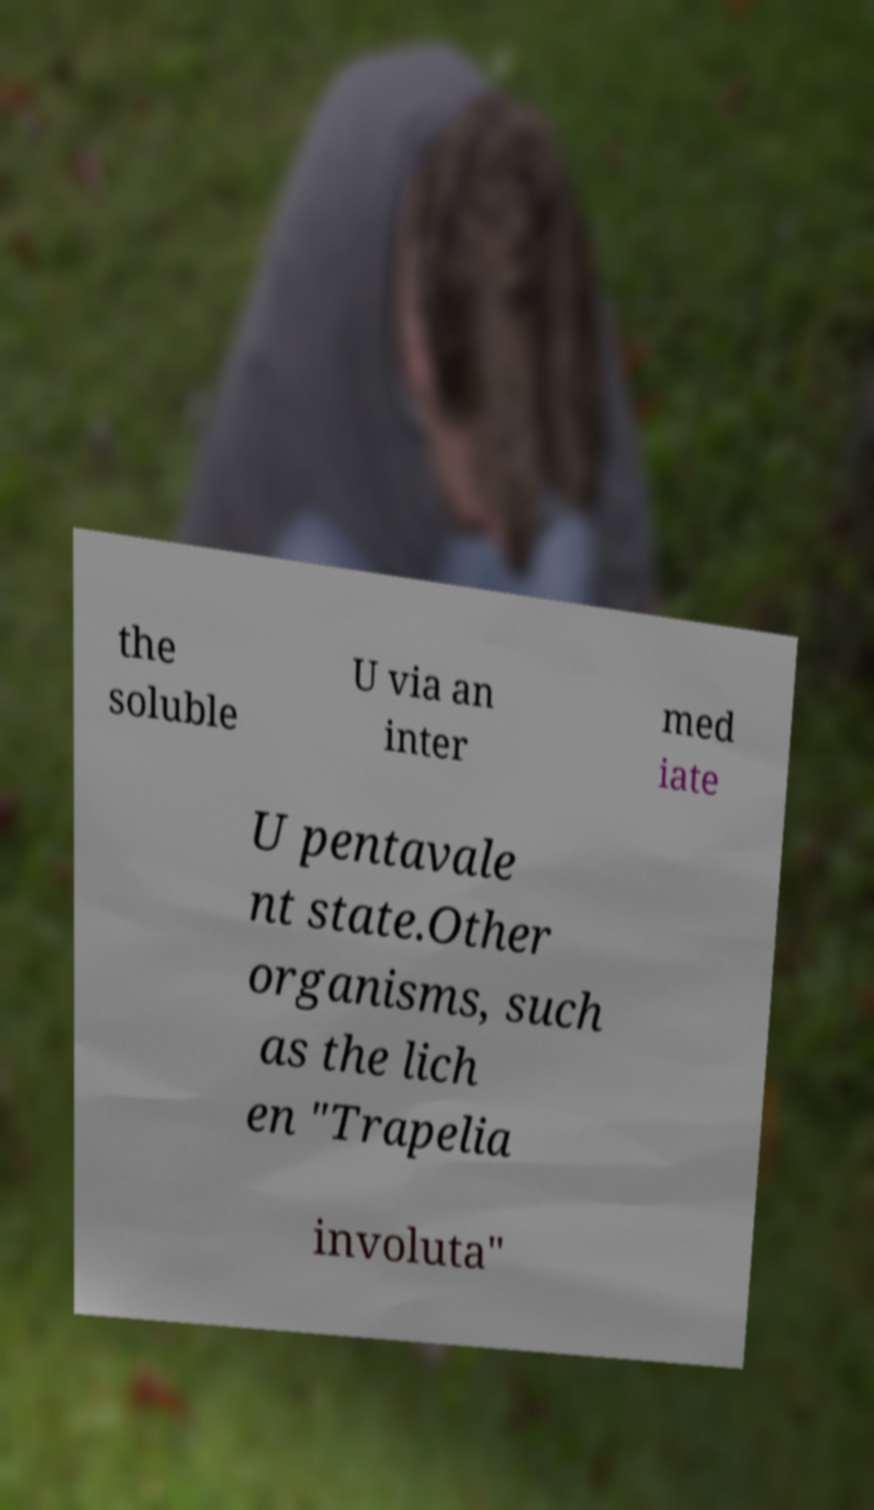Could you extract and type out the text from this image? the soluble U via an inter med iate U pentavale nt state.Other organisms, such as the lich en "Trapelia involuta" 